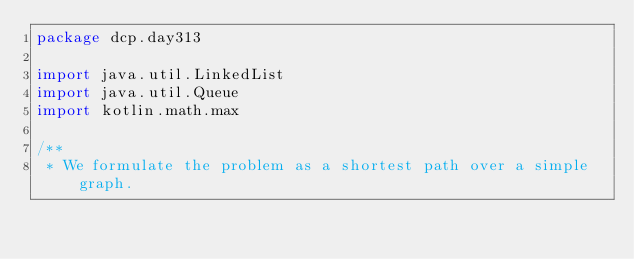<code> <loc_0><loc_0><loc_500><loc_500><_Kotlin_>package dcp.day313

import java.util.LinkedList
import java.util.Queue
import kotlin.math.max

/**
 * We formulate the problem as a shortest path over a simple graph.</code> 